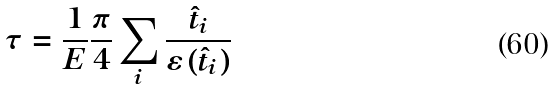<formula> <loc_0><loc_0><loc_500><loc_500>\tau = \frac { 1 } { E } \frac { \pi } { 4 } \sum _ { i } \frac { \hat { t } _ { i } } { \varepsilon ( \hat { t } _ { i } ) }</formula> 